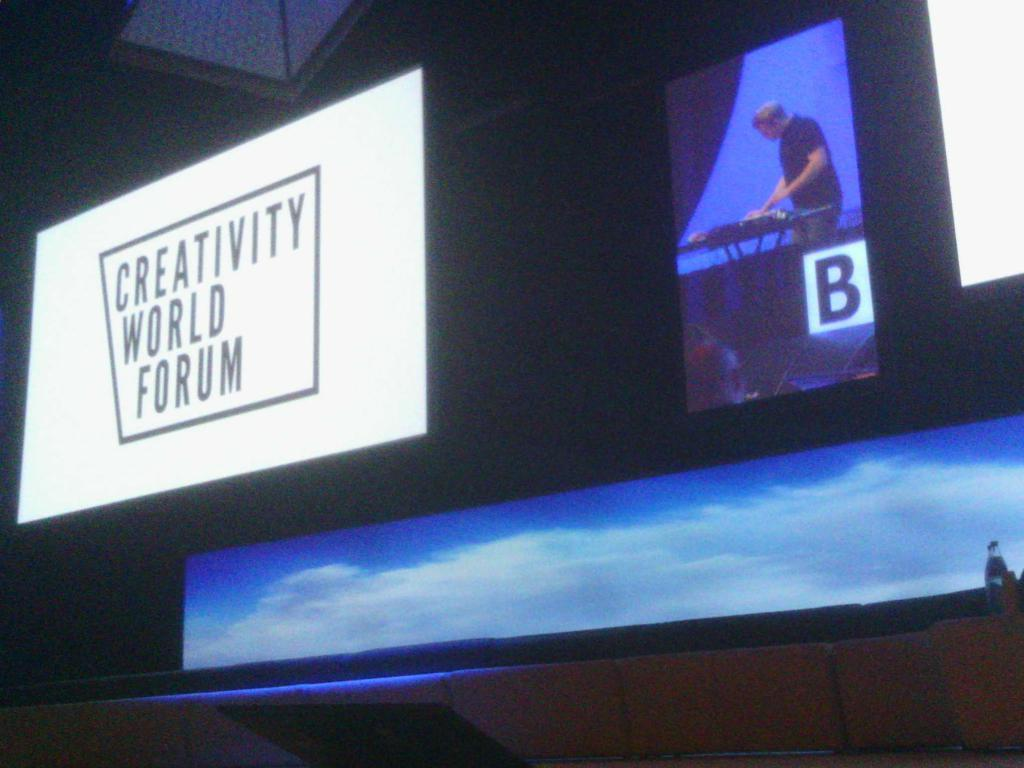Provide a one-sentence caption for the provided image. Creativity world forum in big on a big television with a man in the background. 